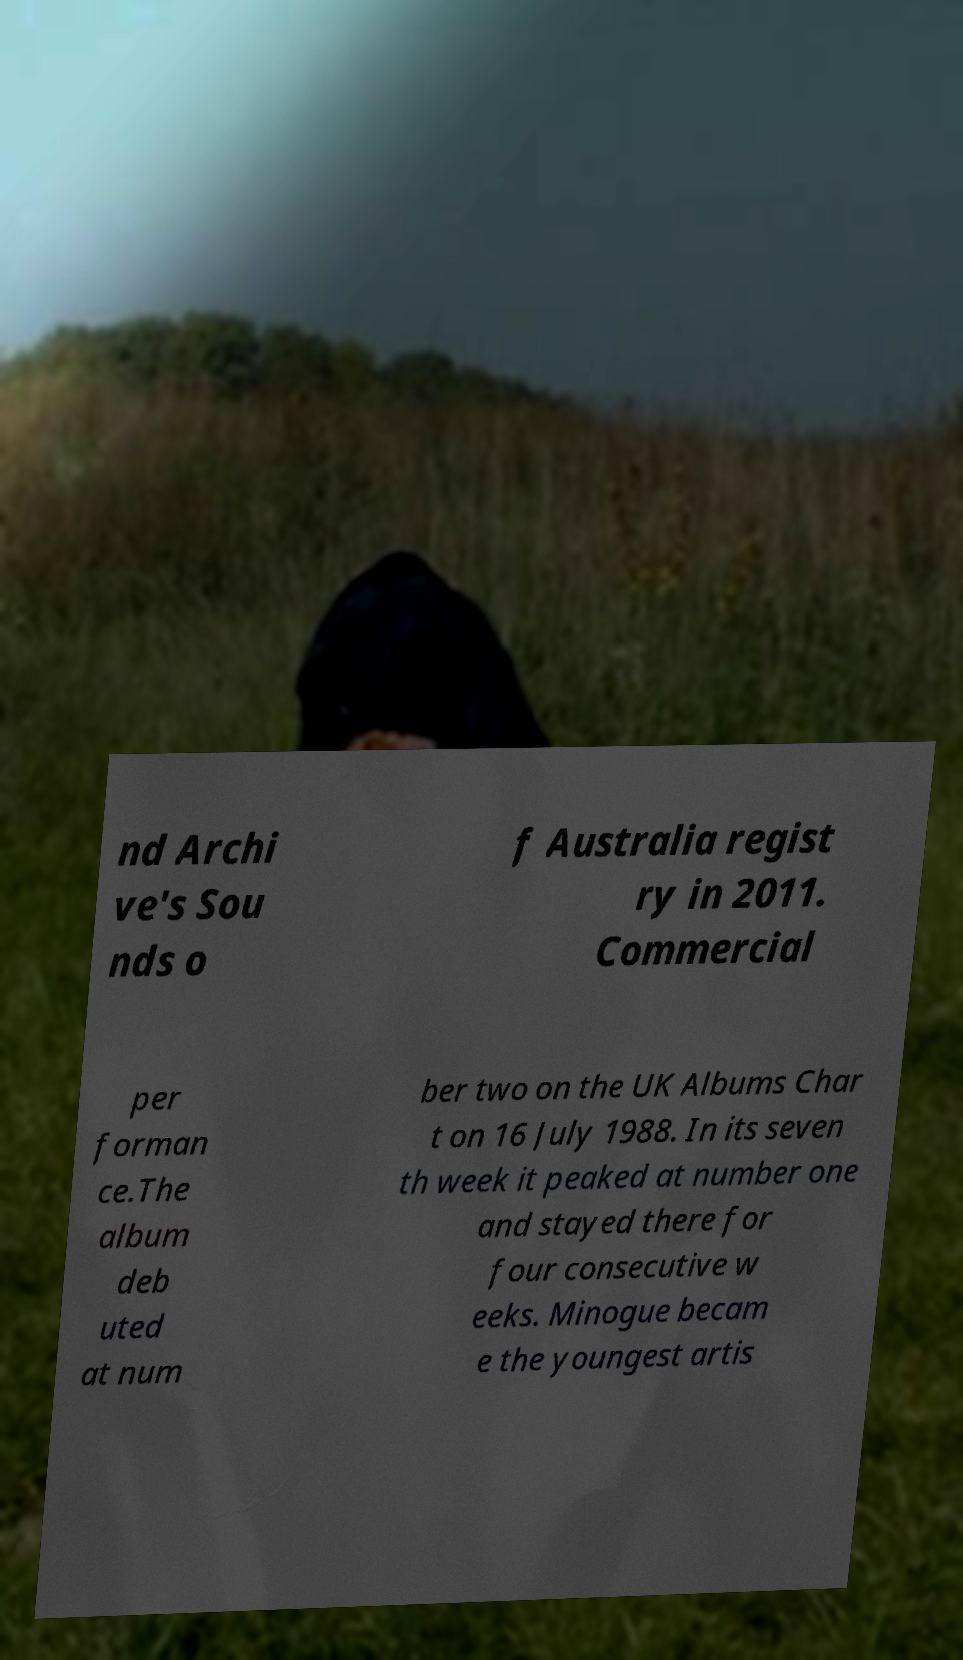Can you read and provide the text displayed in the image?This photo seems to have some interesting text. Can you extract and type it out for me? nd Archi ve's Sou nds o f Australia regist ry in 2011. Commercial per forman ce.The album deb uted at num ber two on the UK Albums Char t on 16 July 1988. In its seven th week it peaked at number one and stayed there for four consecutive w eeks. Minogue becam e the youngest artis 